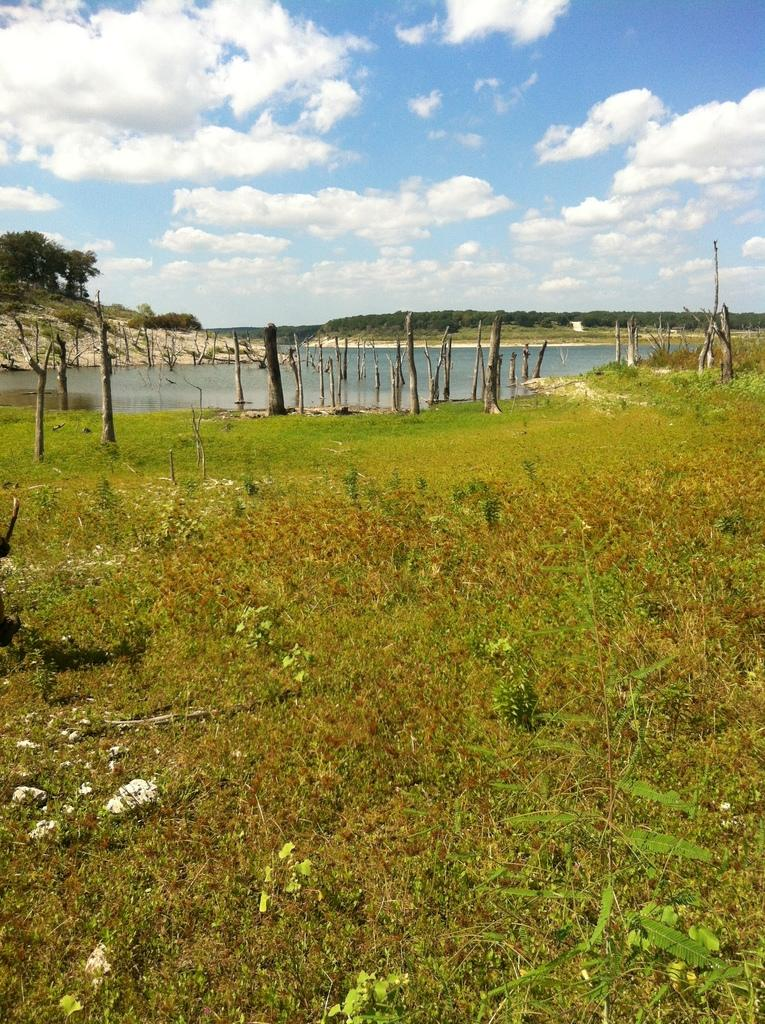What type of vegetation is on the ground in the image? There are plants and grass on the ground in the image. What can be seen in the background of the image? There are wooden poles, water, trees, and the sky visible in the background. What is the condition of the sky in the image? The sky is visible in the background, and clouds are present. Can you tell me how many pets are visible in the image? There are no pets present in the image. What type of ear is attached to the wooden poles in the image? There are no ears attached to the wooden poles in the image; they are simply poles. 